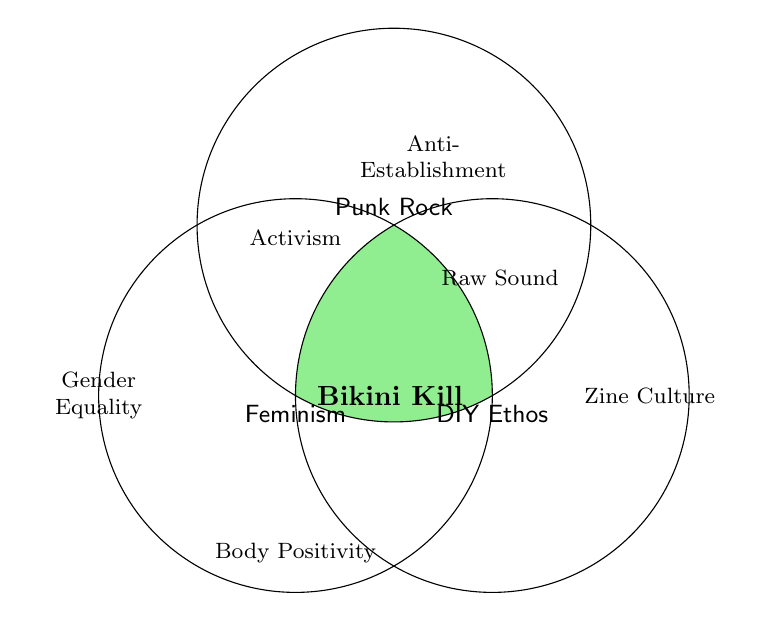What are the three main themes in the Venn Diagram? The Venn Diagram represents three main themes by placing each at the center of a circle; these themes are identified as Feminism, Punk Rock, and DIY Ethos.
Answer: Feminism, Punk Rock, DIY Ethos Which band is associated with the intersection of all three themes? The intersection of the three circles labeled Feminism, Punk Rock, and DIY Ethos contains the band Bikini Kill, representing that this band covers all three themes.
Answer: Bikini Kill How many themes does the Venn Diagram include overall? By counting both the main themes in the circles and additional themes outside them, there are a total of ten themes.
Answer: Ten What themes intersect to include the theme 'Activism'? 'Activism' is positioned inside the Punk Rock circle and not intersecting with either Feminism or DIY Ethos, indicating it's a sub-theme within the Punk Rock category.
Answer: Punk Rock Which themes include the band L7 within their intersection? The band L7 appears at the intersection between Gender Equality, Anti-Establishment, and DIY Ethos, all related themes visible in the diagram.
Answer: Gender Equality, Anti-Establishment, DIY Ethos Is 'Gender Equality' directly associated with the theme DIY Ethos? 'Gender Equality' is outside the DIY Ethos circle, indicating that it is not directly associated with DIY Ethos but stands on its own.
Answer: No Which theme is directly linked to 'Zine Culture'? 'Zine Culture' is inside the DIY Ethos circle, showing it is a direct sub-theme under DIY Ethos.
Answer: DIY Ethos What is the common area of themes where L7 is found? L7 is located specifically at the intersection of Gender Equality, Anti-Establishment, and DIY Ethos, making it part of those overlapping themes.
Answer: Gender Equality, Anti-Establishment, DIY Ethos 